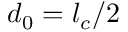Convert formula to latex. <formula><loc_0><loc_0><loc_500><loc_500>d _ { 0 } = l _ { c } / 2</formula> 